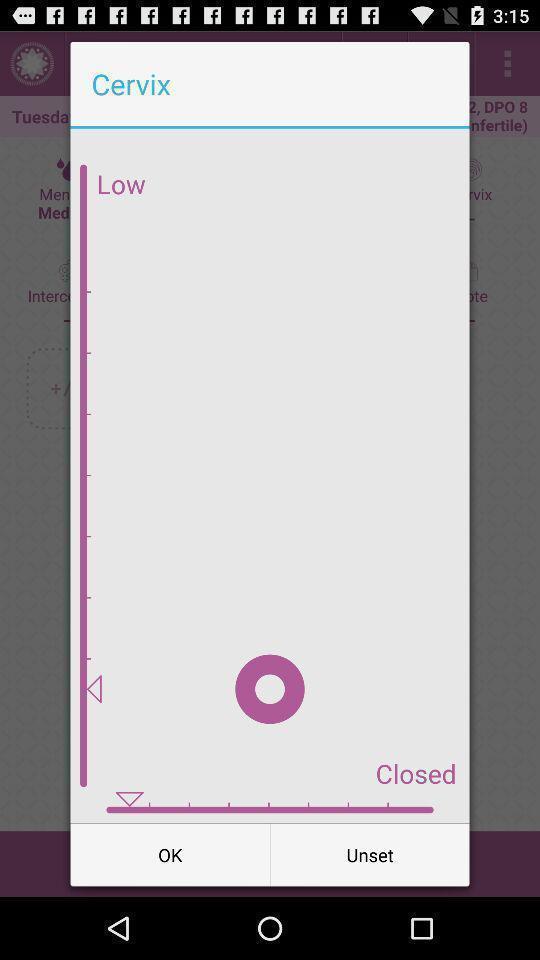Give me a summary of this screen capture. Push up notification showing some results. 